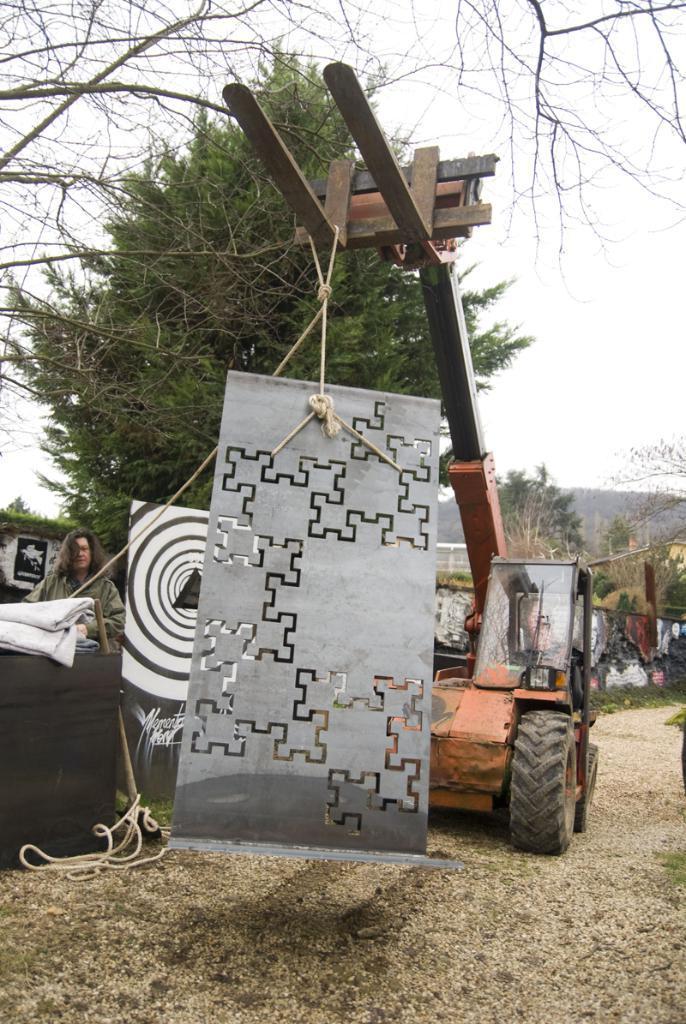Can you describe this image briefly? In this image I can see a vehicle in orange color, in front I can see some object which is in gray color, at left I can see a person standing, at the background I can see trees in green color and sky in white color. 